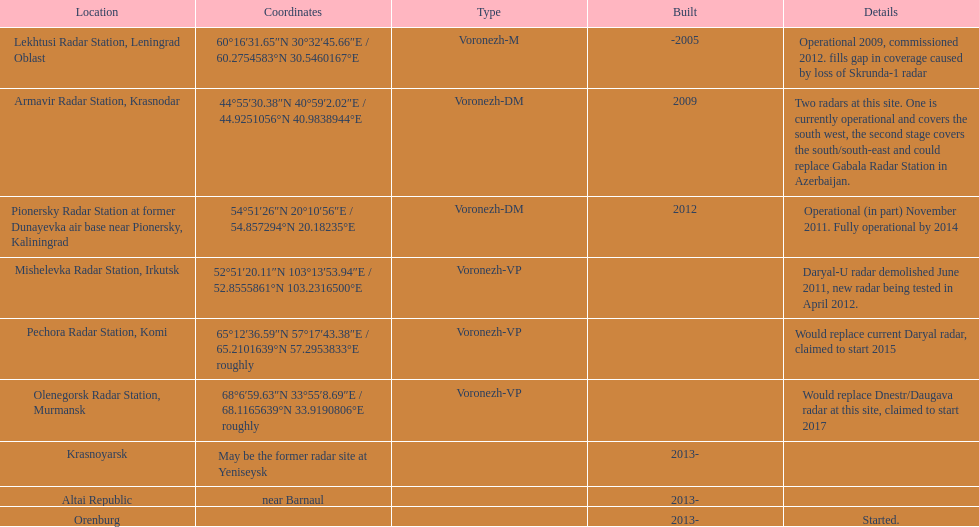What is the total number of locations? 9. 